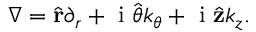Convert formula to latex. <formula><loc_0><loc_0><loc_500><loc_500>\begin{array} { r } { \nabla = \hat { r } \partial _ { r } + i \hat { \theta } k _ { \theta } + i \hat { z } k _ { z } . } \end{array}</formula> 